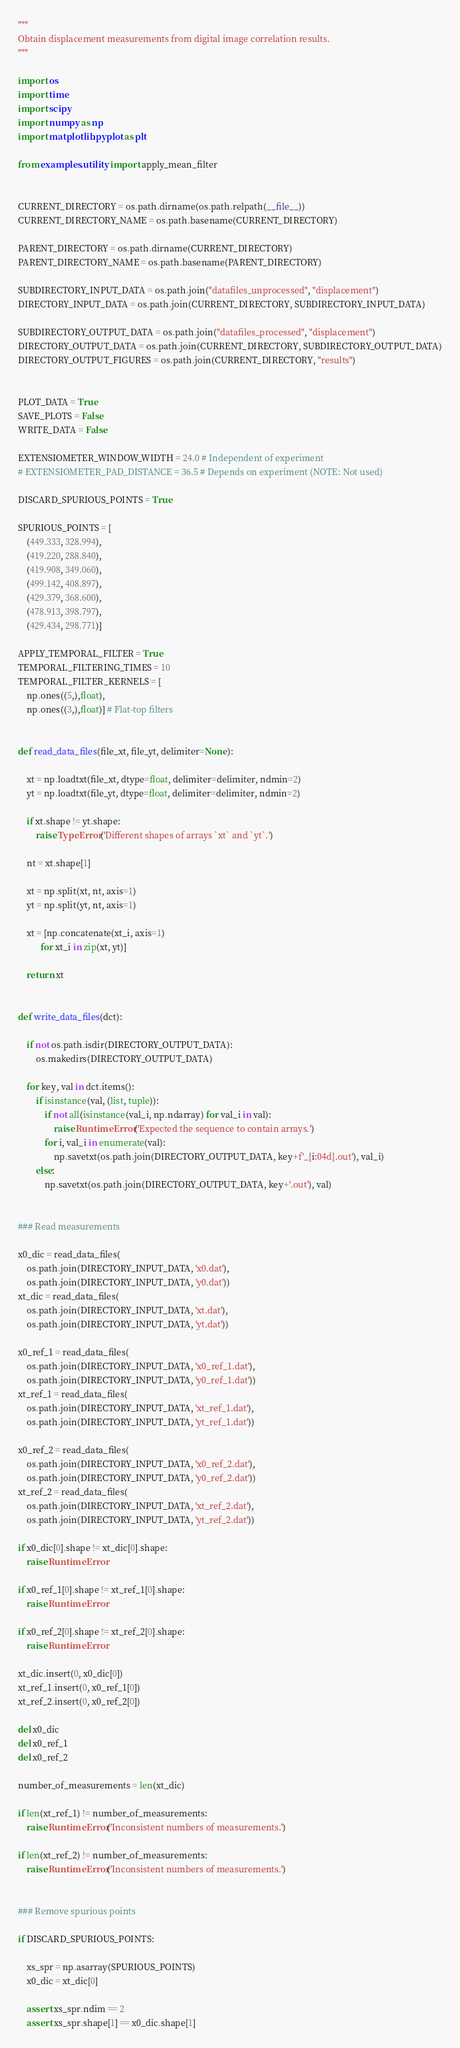<code> <loc_0><loc_0><loc_500><loc_500><_Python_>"""
Obtain displacement measurements from digital image correlation results.
"""

import os
import time
import scipy
import numpy as np
import matplotlib.pyplot as plt

from examples.utility import apply_mean_filter


CURRENT_DIRECTORY = os.path.dirname(os.path.relpath(__file__))
CURRENT_DIRECTORY_NAME = os.path.basename(CURRENT_DIRECTORY)

PARENT_DIRECTORY = os.path.dirname(CURRENT_DIRECTORY)
PARENT_DIRECTORY_NAME = os.path.basename(PARENT_DIRECTORY)

SUBDIRECTORY_INPUT_DATA = os.path.join("datafiles_unprocessed", "displacement")
DIRECTORY_INPUT_DATA = os.path.join(CURRENT_DIRECTORY, SUBDIRECTORY_INPUT_DATA)

SUBDIRECTORY_OUTPUT_DATA = os.path.join("datafiles_processed", "displacement")
DIRECTORY_OUTPUT_DATA = os.path.join(CURRENT_DIRECTORY, SUBDIRECTORY_OUTPUT_DATA)
DIRECTORY_OUTPUT_FIGURES = os.path.join(CURRENT_DIRECTORY, "results")


PLOT_DATA = True
SAVE_PLOTS = False
WRITE_DATA = False

EXTENSIOMETER_WINDOW_WIDTH = 24.0 # Independent of experiment
# EXTENSIOMETER_PAD_DISTANCE = 36.5 # Depends on experiment (NOTE: Not used)

DISCARD_SPURIOUS_POINTS = True

SPURIOUS_POINTS = [
    (449.333, 328.994),
    (419.220, 288.840),
    (419.908, 349.060),
    (499.142, 408.897),
    (429.379, 368.600),
    (478.913, 398.797),
    (429.434, 298.771)]

APPLY_TEMPORAL_FILTER = True
TEMPORAL_FILTERING_TIMES = 10
TEMPORAL_FILTER_KERNELS = [
    np.ones((5,),float),
    np.ones((3,),float)] # Flat-top filters


def read_data_files(file_xt, file_yt, delimiter=None):

    xt = np.loadtxt(file_xt, dtype=float, delimiter=delimiter, ndmin=2)
    yt = np.loadtxt(file_yt, dtype=float, delimiter=delimiter, ndmin=2)

    if xt.shape != yt.shape:
        raise TypeError('Different shapes of arrays `xt` and `yt`.')

    nt = xt.shape[1]

    xt = np.split(xt, nt, axis=1)
    yt = np.split(yt, nt, axis=1)

    xt = [np.concatenate(xt_i, axis=1)
          for xt_i in zip(xt, yt)]

    return xt


def write_data_files(dct):

    if not os.path.isdir(DIRECTORY_OUTPUT_DATA):
        os.makedirs(DIRECTORY_OUTPUT_DATA)

    for key, val in dct.items():
        if isinstance(val, (list, tuple)):
            if not all(isinstance(val_i, np.ndarray) for val_i in val):
                raise RuntimeError('Expected the sequence to contain arrays.')
            for i, val_i in enumerate(val):
                np.savetxt(os.path.join(DIRECTORY_OUTPUT_DATA, key+f'_{i:04d}.out'), val_i)
        else:
            np.savetxt(os.path.join(DIRECTORY_OUTPUT_DATA, key+'.out'), val)


### Read measurements

x0_dic = read_data_files(
    os.path.join(DIRECTORY_INPUT_DATA, 'x0.dat'),
    os.path.join(DIRECTORY_INPUT_DATA, 'y0.dat'))
xt_dic = read_data_files(
    os.path.join(DIRECTORY_INPUT_DATA, 'xt.dat'),
    os.path.join(DIRECTORY_INPUT_DATA, 'yt.dat'))

x0_ref_1 = read_data_files(
    os.path.join(DIRECTORY_INPUT_DATA, 'x0_ref_1.dat'),
    os.path.join(DIRECTORY_INPUT_DATA, 'y0_ref_1.dat'))
xt_ref_1 = read_data_files(
    os.path.join(DIRECTORY_INPUT_DATA, 'xt_ref_1.dat'),
    os.path.join(DIRECTORY_INPUT_DATA, 'yt_ref_1.dat'))

x0_ref_2 = read_data_files(
    os.path.join(DIRECTORY_INPUT_DATA, 'x0_ref_2.dat'),
    os.path.join(DIRECTORY_INPUT_DATA, 'y0_ref_2.dat'))
xt_ref_2 = read_data_files(
    os.path.join(DIRECTORY_INPUT_DATA, 'xt_ref_2.dat'),
    os.path.join(DIRECTORY_INPUT_DATA, 'yt_ref_2.dat'))

if x0_dic[0].shape != xt_dic[0].shape:
    raise RuntimeError

if x0_ref_1[0].shape != xt_ref_1[0].shape:
    raise RuntimeError

if x0_ref_2[0].shape != xt_ref_2[0].shape:
    raise RuntimeError

xt_dic.insert(0, x0_dic[0])
xt_ref_1.insert(0, x0_ref_1[0])
xt_ref_2.insert(0, x0_ref_2[0])

del x0_dic
del x0_ref_1
del x0_ref_2

number_of_measurements = len(xt_dic)

if len(xt_ref_1) != number_of_measurements:
    raise RuntimeError('Inconsistent numbers of measurements.')

if len(xt_ref_2) != number_of_measurements:
    raise RuntimeError('Inconsistent numbers of measurements.')


### Remove spurious points

if DISCARD_SPURIOUS_POINTS:

    xs_spr = np.asarray(SPURIOUS_POINTS)
    x0_dic = xt_dic[0]

    assert xs_spr.ndim == 2
    assert xs_spr.shape[1] == x0_dic.shape[1]
</code> 